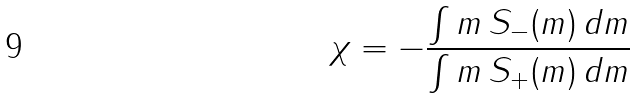Convert formula to latex. <formula><loc_0><loc_0><loc_500><loc_500>\chi = - \frac { \int m \, S _ { - } ( m ) \, d m } { \int m \, S _ { + } ( m ) \, d m }</formula> 